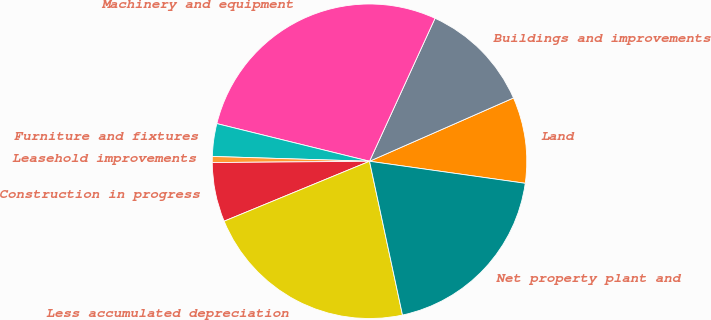<chart> <loc_0><loc_0><loc_500><loc_500><pie_chart><fcel>Land<fcel>Buildings and improvements<fcel>Machinery and equipment<fcel>Furniture and fixtures<fcel>Leasehold improvements<fcel>Construction in progress<fcel>Less accumulated depreciation<fcel>Net property plant and<nl><fcel>8.83%<fcel>11.57%<fcel>27.99%<fcel>3.36%<fcel>0.62%<fcel>6.09%<fcel>22.14%<fcel>19.4%<nl></chart> 